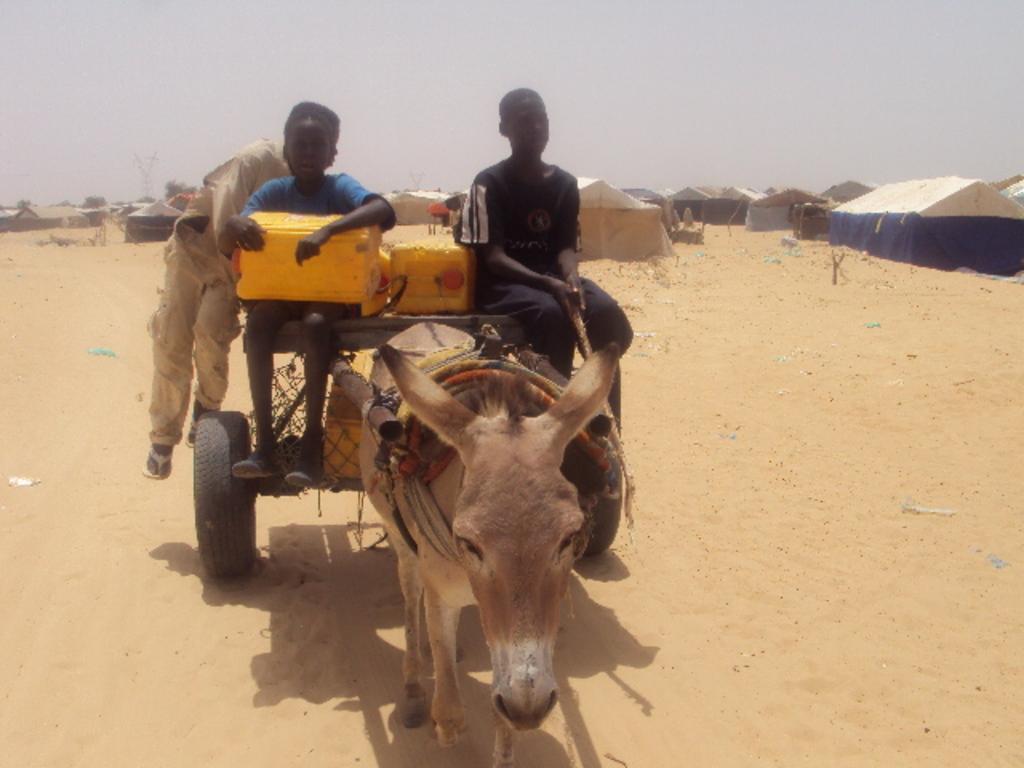How would you summarize this image in a sentence or two? In this picture I can see a donkey in front and I see a cart attached to it and I see 3 boys and 2 containers on the cart and I see the sand. In the background I see number of tents and the clear sky. 